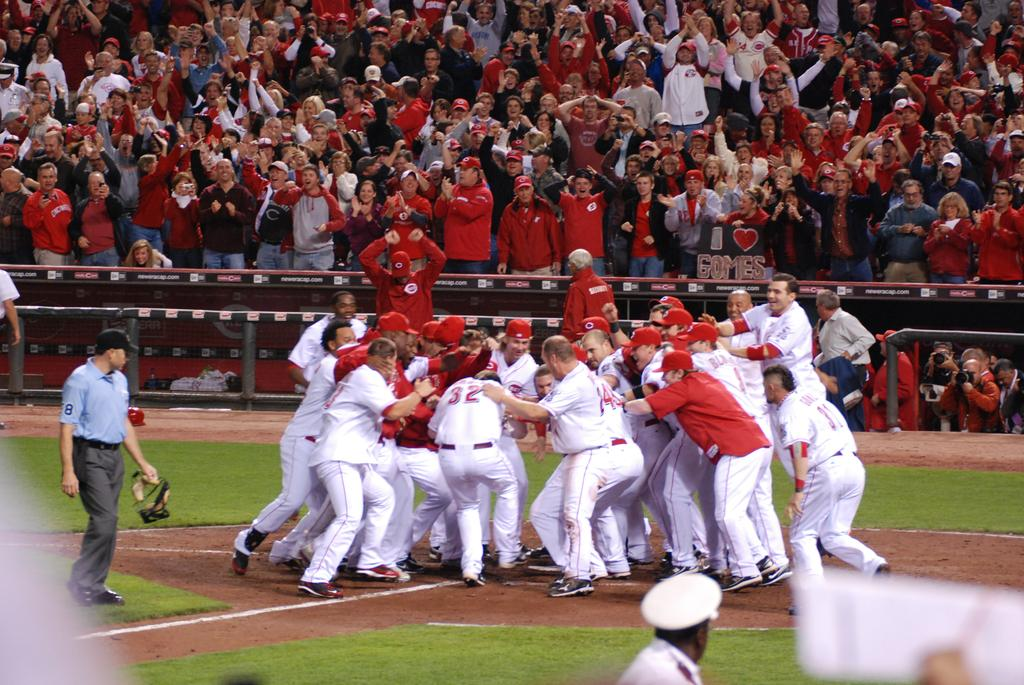<image>
Render a clear and concise summary of the photo. the number 32 is on the back of a player 